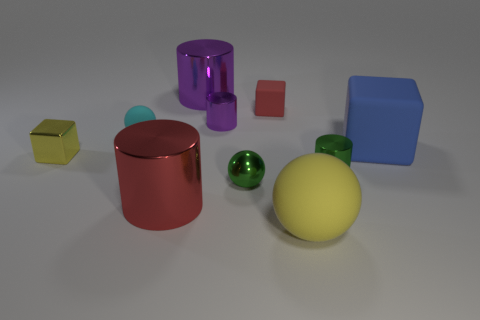What number of big matte things are behind the tiny green metallic ball?
Ensure brevity in your answer.  1. What material is the red object that is on the left side of the tiny purple cylinder that is to the left of the blue block made of?
Your answer should be compact. Metal. Is there a large metallic thing of the same color as the small matte cube?
Offer a terse response. Yes. What is the size of the yellow ball that is the same material as the blue object?
Give a very brief answer. Large. Are there any other things of the same color as the metal sphere?
Keep it short and to the point. Yes. What is the color of the tiny metallic cylinder in front of the large block?
Your answer should be compact. Green. There is a matte object that is in front of the tiny object that is left of the small rubber ball; is there a small cyan rubber ball left of it?
Your answer should be very brief. Yes. Is the number of yellow rubber balls that are left of the large blue cube greater than the number of tiny blue metal objects?
Ensure brevity in your answer.  Yes. There is a small shiny object to the left of the small cyan rubber object; is its shape the same as the tiny cyan object?
Provide a succinct answer. No. How many objects are cylinders or tiny balls right of the large red metal object?
Offer a terse response. 5. 